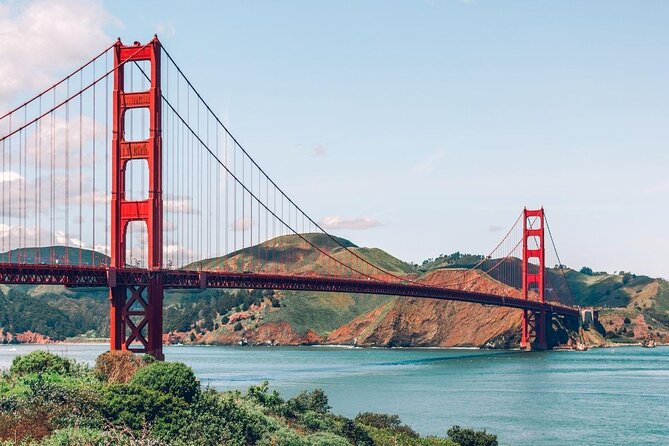This structure looks magnificent! What are some unique historical facts about it? The Golden Gate Bridge, completed in 1937, was once the longest and tallest suspension bridge in the world. Interestingly, the bridge's distinctive color was chosen not just for its visual appeal, but also because it provides visibility in the frequent fogs of San Francisco. It was initially considered to be painted black with yellow stripes! Another fascinating fact is that during its construction, safety nets saved the lives of 19 men, who later formed the Halfway to Hell Club. 